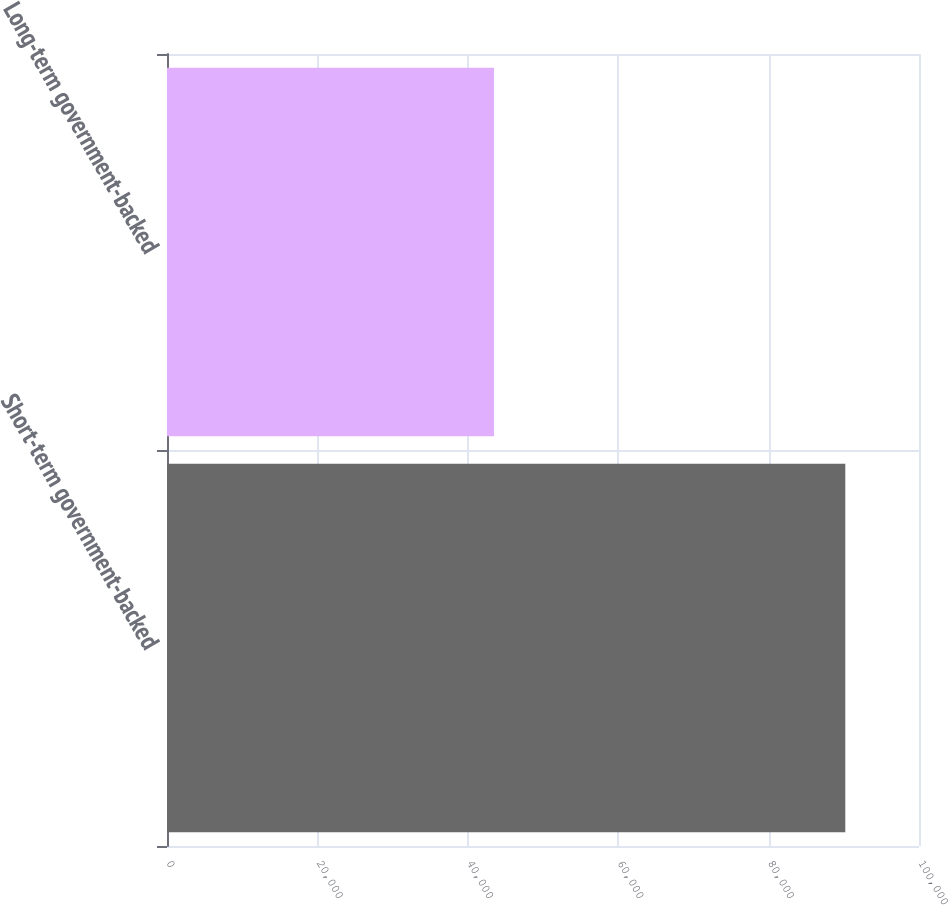Convert chart. <chart><loc_0><loc_0><loc_500><loc_500><bar_chart><fcel>Short-term government-backed<fcel>Long-term government-backed<nl><fcel>90199<fcel>43484<nl></chart> 